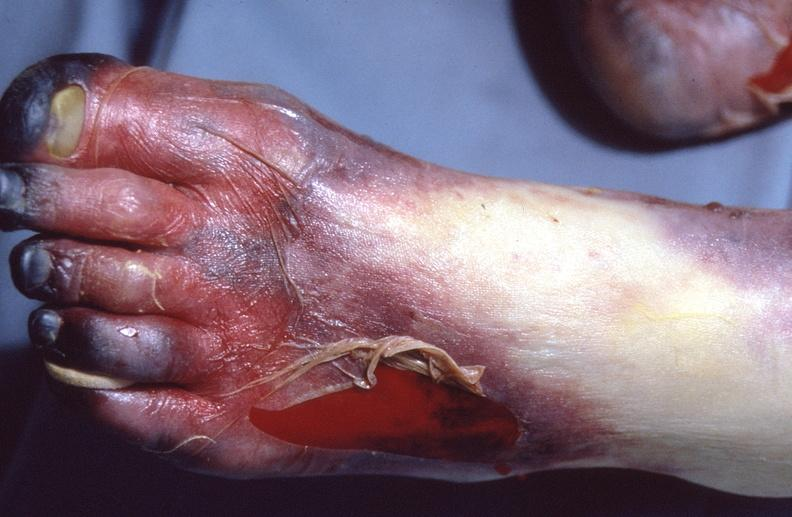does this image show skin ulceration and necrosis, disseminated intravascular coagulation due to acetaminophen toxicity?
Answer the question using a single word or phrase. Yes 